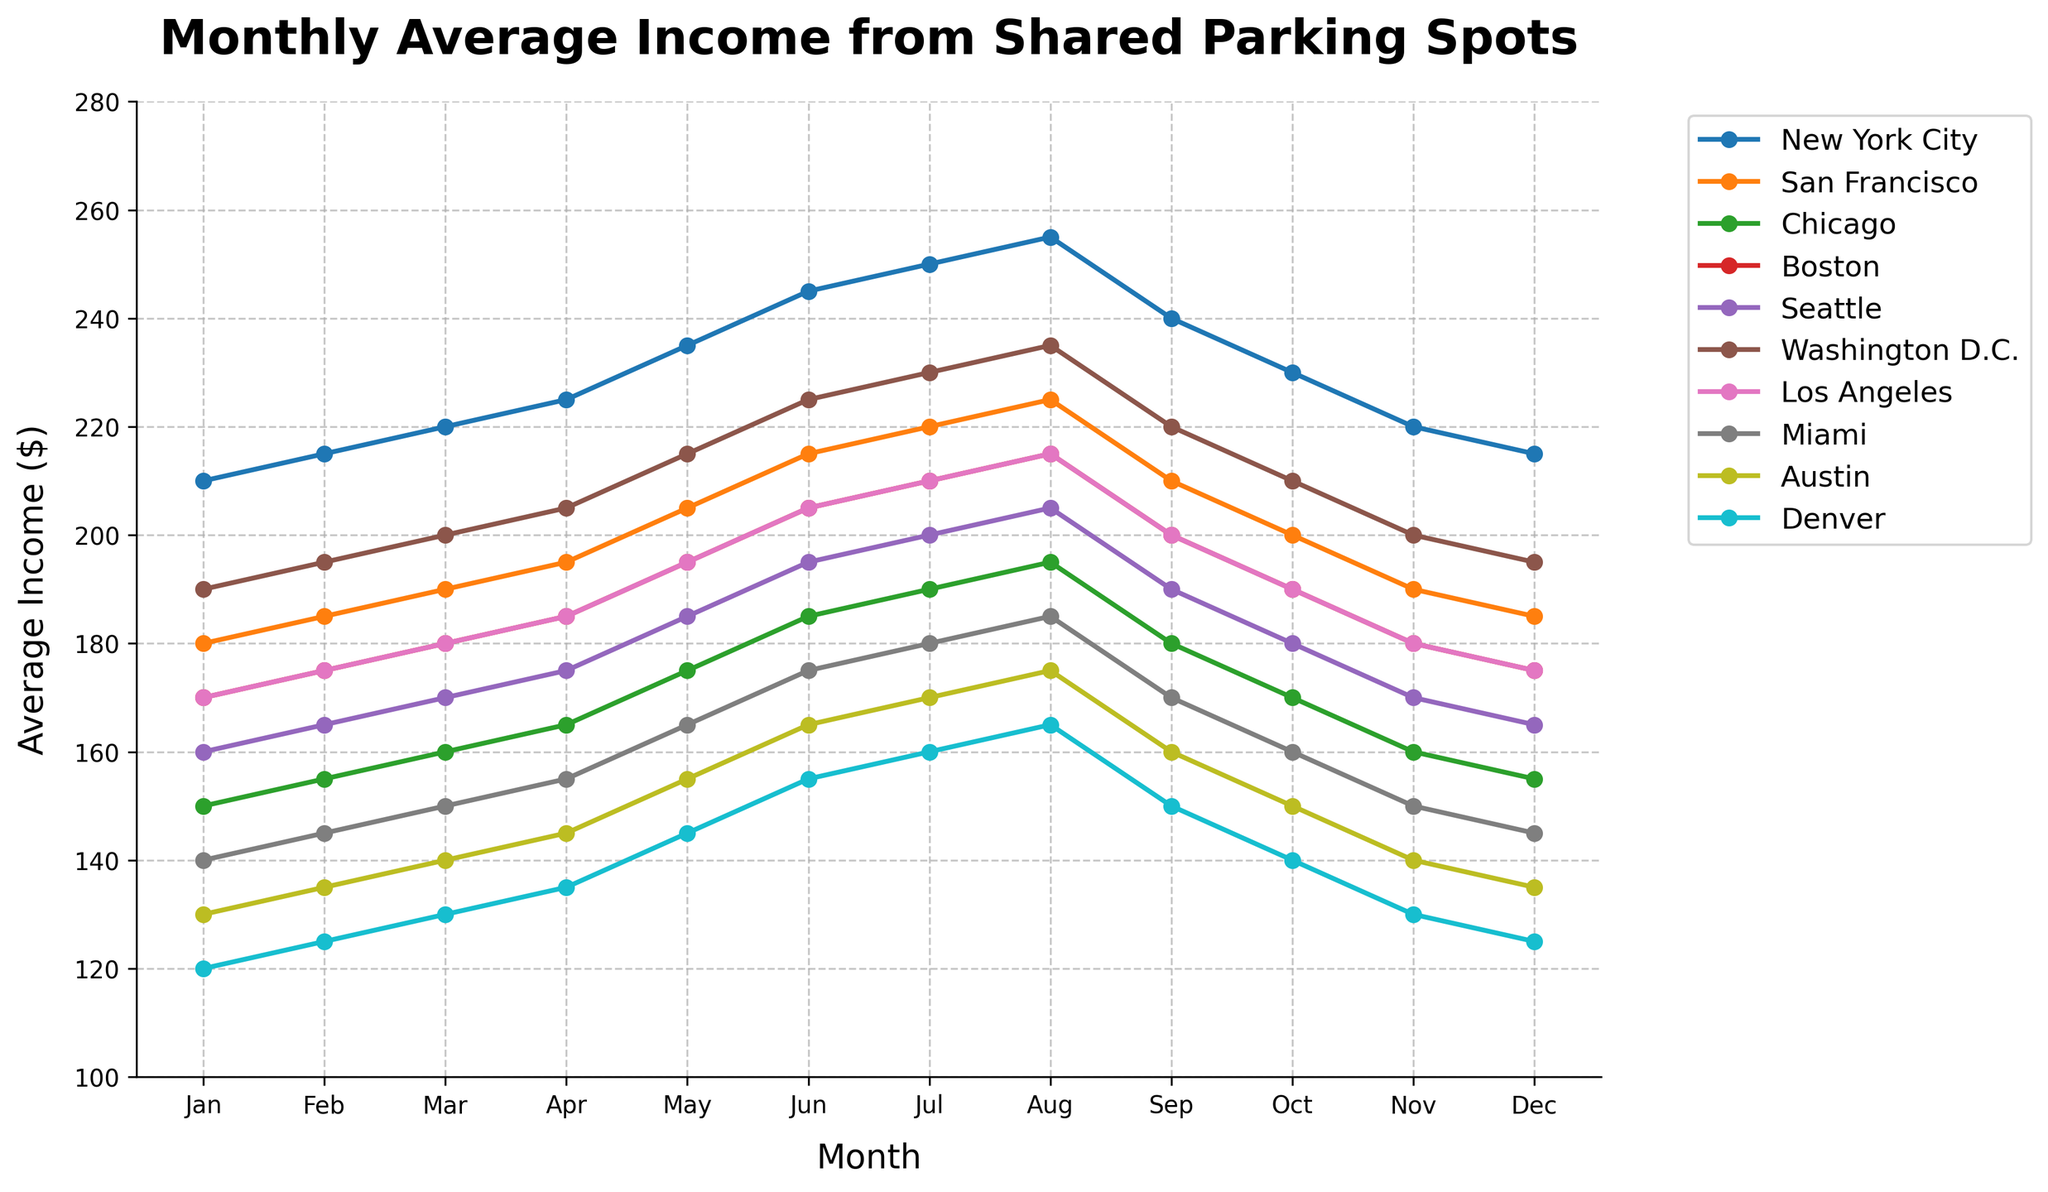Which city had the highest average income in December? To determine this, locate the December data points for all cities on the chart and find the highest value. New York City has the highest income, with 215 dollars in December.
Answer: New York City Which month did Miami see its highest income from shared parking spots? Identify the peak point in Miami's income line on the chart. Miami's highest income is in July, with 185 dollars.
Answer: July What is the difference in income between New York City and Denver for June? Find the June data points for both New York City and Denver. New York City's income is 245 dollars, and Denver's is 155 dollars. The difference is 245 - 155 = 90 dollars.
Answer: 90 dollars Which city showed the most consistent income throughout the year? Look for the city with the smallest fluctuations in their line throughout the year. San Francisco's line is relatively flat compared to others.
Answer: San Francisco How much did the income in Seattle increase from January to July? Find Seattle's income for January and July. In January, it is 160 dollars, and in July, it is 200 dollars. The increase is 200 - 160 = 40 dollars.
Answer: 40 dollars Which city had the largest drop in income from August to December? Identify the cities and compare the income values in August and December, noting the differences. Denver had the largest drop, from 165 dollars in August to 125 dollars in December, a 40-dollar decrease.
Answer: Denver By how much did Chicago's income increase from January to October? Check Chicago's income for January and October. In January, it is 150 dollars, and in October, it is 170 dollars. The increase is 170 - 150 = 20 dollars.
Answer: 20 dollars Which month experienced the lowest overall income across all cities? For each month, observe the income levels across all cities and determine which month has the lowest values. January generally has the lowest values, especially comparing to other months.
Answer: January Does Los Angeles surpass Boston in income for any month of the year? Compare the monthly income data of Los Angeles and Boston. Yes, Los Angeles surpasses Boston in July and December.
Answer: Yes What is the average income for Austin from May to August? Sum Austin's income values from May to August and divide by the number of months. Austin's income from May to August is (155 + 165 + 170 + 175) = 665 dollars. The average is 665 / 4 = 166.25 dollars.
Answer: 166.25 dollars 